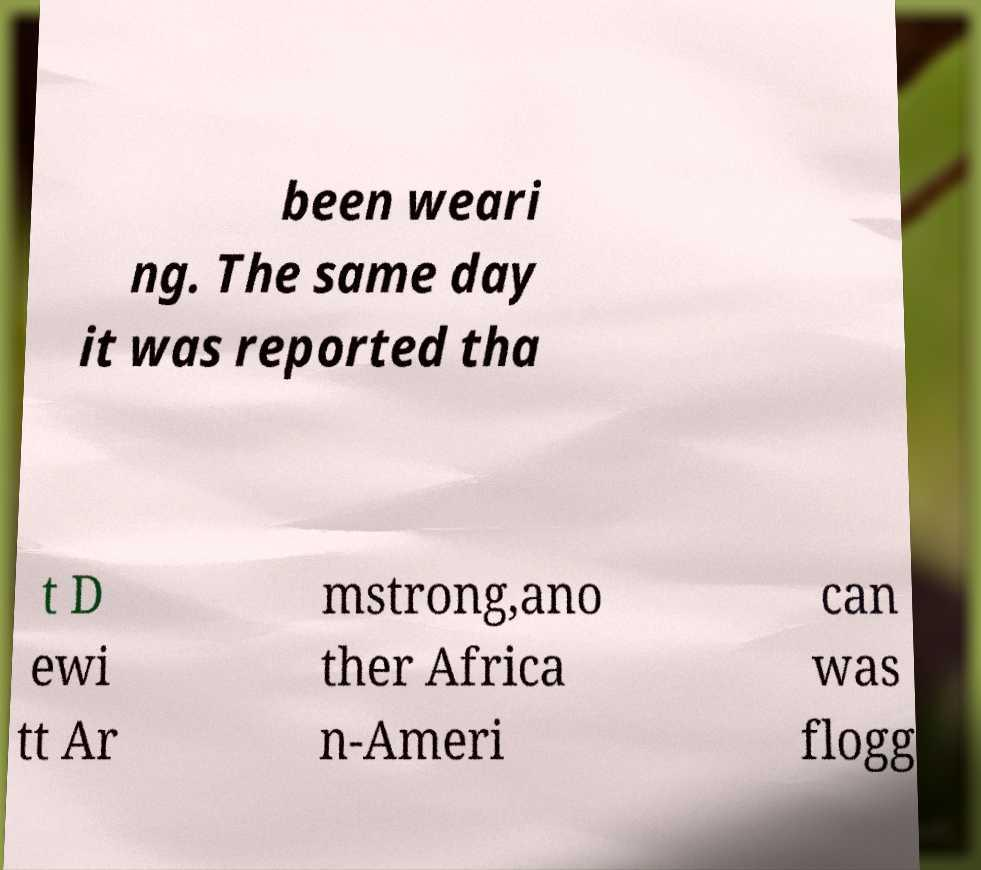Can you read and provide the text displayed in the image?This photo seems to have some interesting text. Can you extract and type it out for me? been weari ng. The same day it was reported tha t D ewi tt Ar mstrong,ano ther Africa n-Ameri can was flogg 